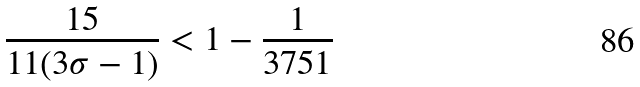Convert formula to latex. <formula><loc_0><loc_0><loc_500><loc_500>\frac { 1 5 } { 1 1 ( 3 \sigma - 1 ) } < 1 - \frac { 1 } { 3 7 5 1 }</formula> 